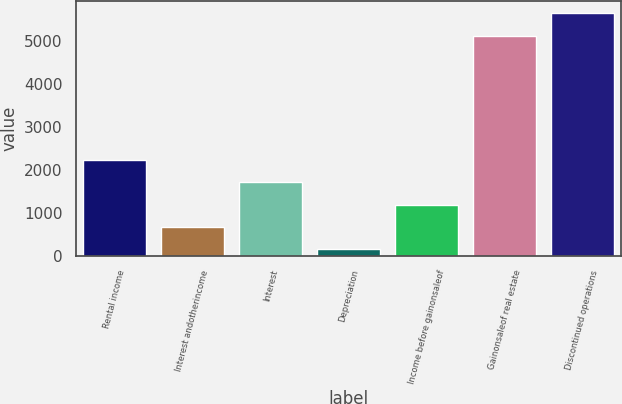Convert chart. <chart><loc_0><loc_0><loc_500><loc_500><bar_chart><fcel>Rental income<fcel>Interest andotherincome<fcel>Interest<fcel>Depreciation<fcel>Income before gainonsaleof<fcel>Gainonsaleof real estate<fcel>Discontinued operations<nl><fcel>2226.2<fcel>671.3<fcel>1707.9<fcel>153<fcel>1189.6<fcel>5114<fcel>5632.3<nl></chart> 